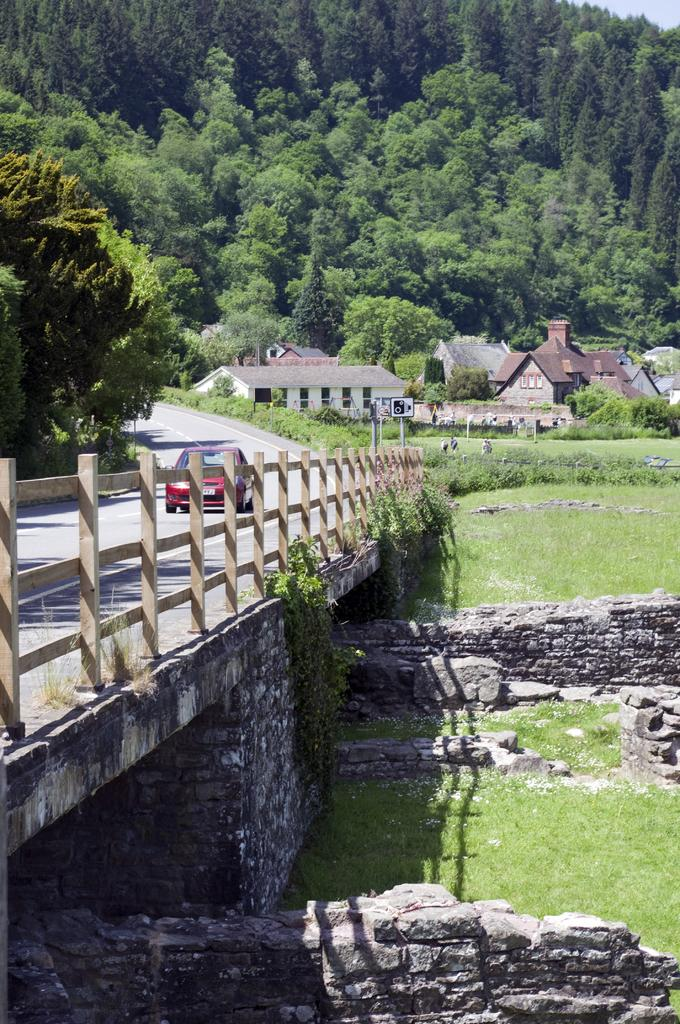What is the main subject of the image? There is a car in the image. Where is the car located? The car is on a bridge. What type of natural environment can be seen in the image? There are trees and grass visible in the image. What type of structures can be seen in the image? There are houses in the image. What other objects can be seen in the image? There are rocks in the image. What color is the sky in the image? There is no sky visible in the image; it is focused on the car, bridge, and surrounding environment. Can you tell me how many cannons are present in the image? There are no cannons present in the image. 